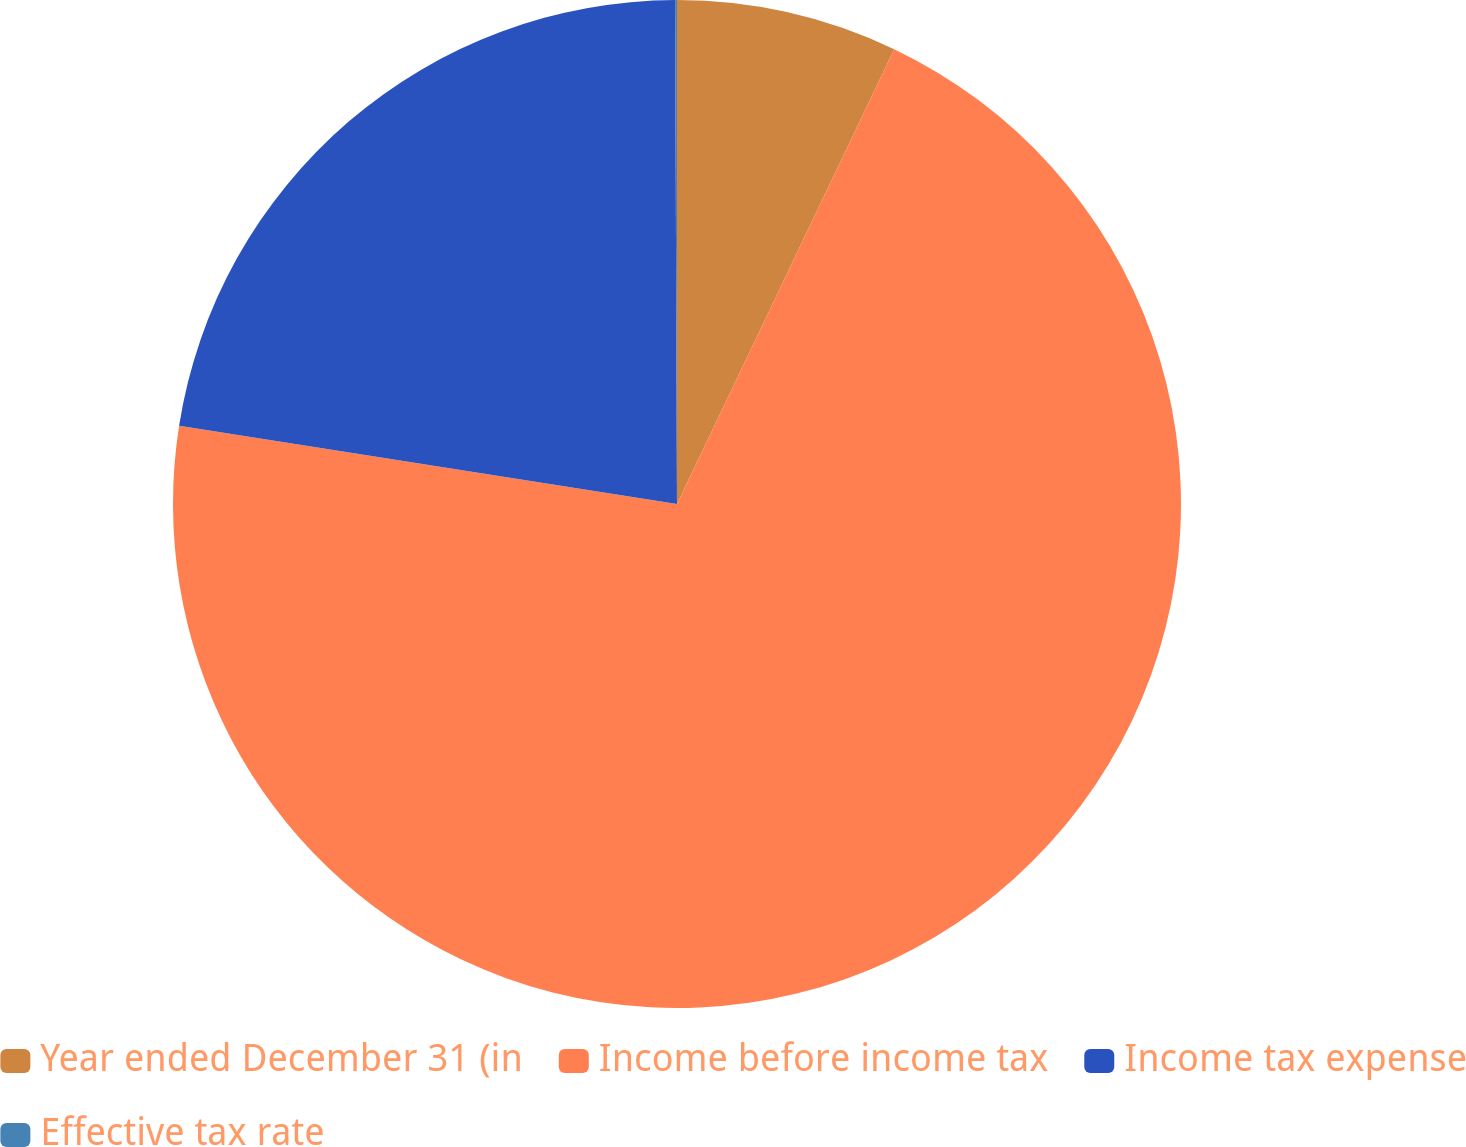Convert chart to OTSL. <chart><loc_0><loc_0><loc_500><loc_500><pie_chart><fcel>Year ended December 31 (in<fcel>Income before income tax<fcel>Income tax expense<fcel>Effective tax rate<nl><fcel>7.09%<fcel>70.38%<fcel>22.46%<fcel>0.06%<nl></chart> 